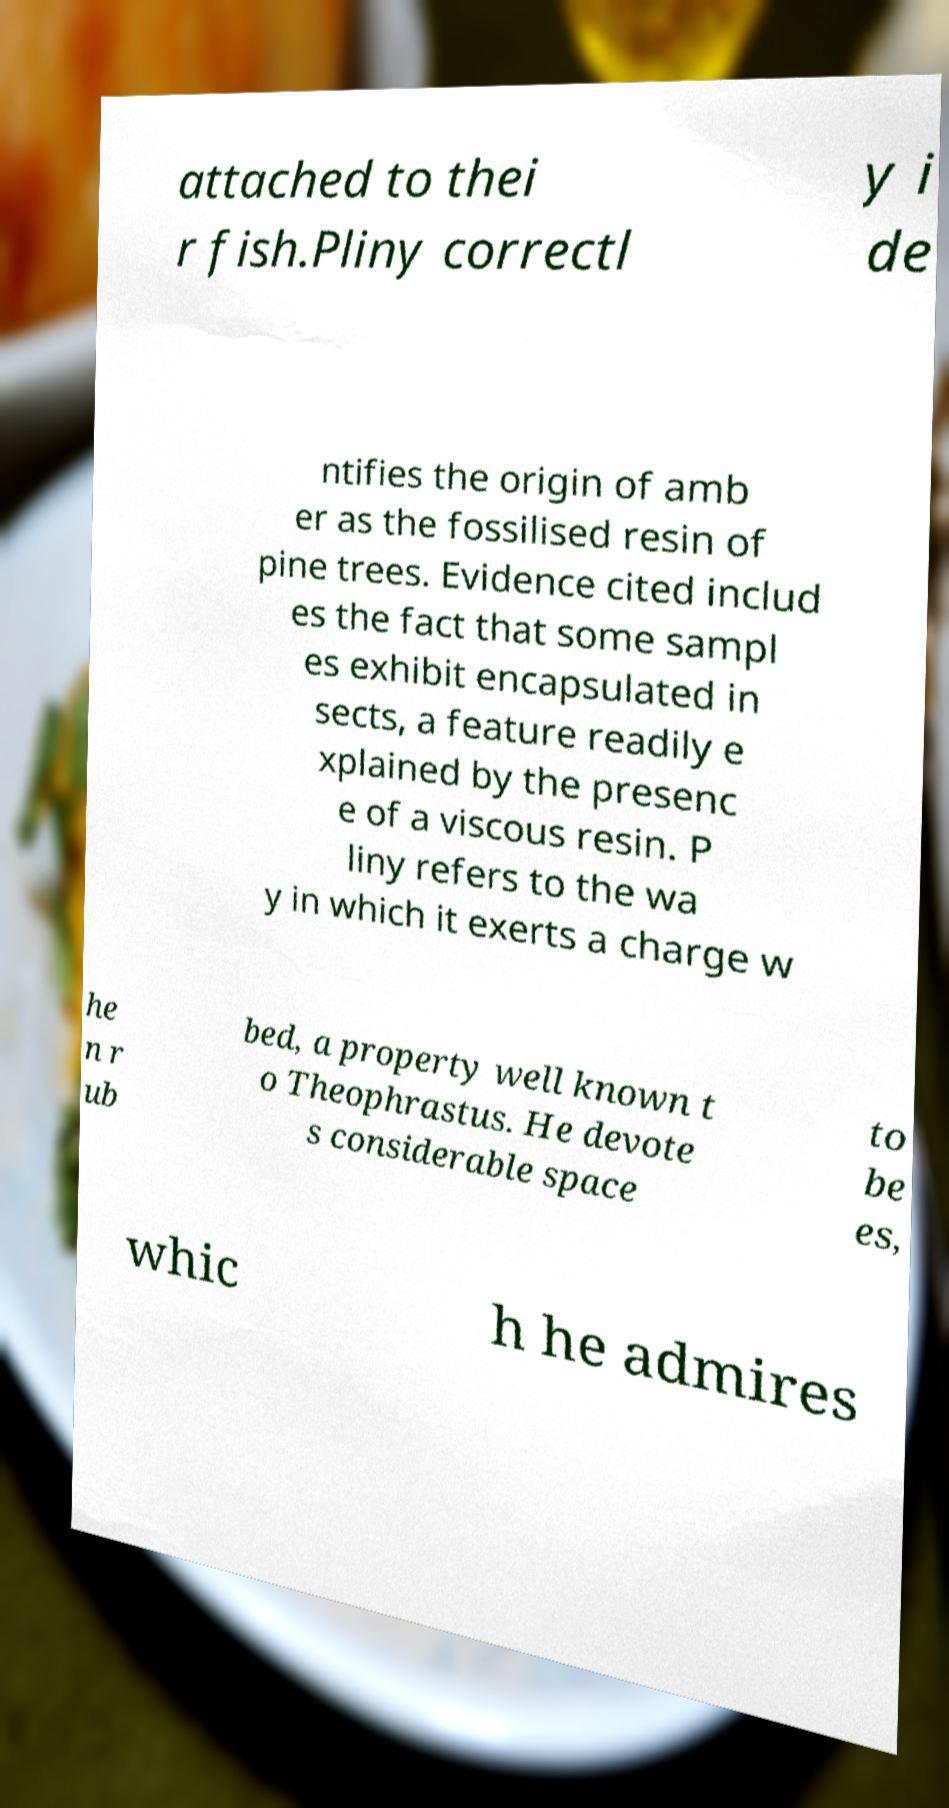Could you extract and type out the text from this image? attached to thei r fish.Pliny correctl y i de ntifies the origin of amb er as the fossilised resin of pine trees. Evidence cited includ es the fact that some sampl es exhibit encapsulated in sects, a feature readily e xplained by the presenc e of a viscous resin. P liny refers to the wa y in which it exerts a charge w he n r ub bed, a property well known t o Theophrastus. He devote s considerable space to be es, whic h he admires 